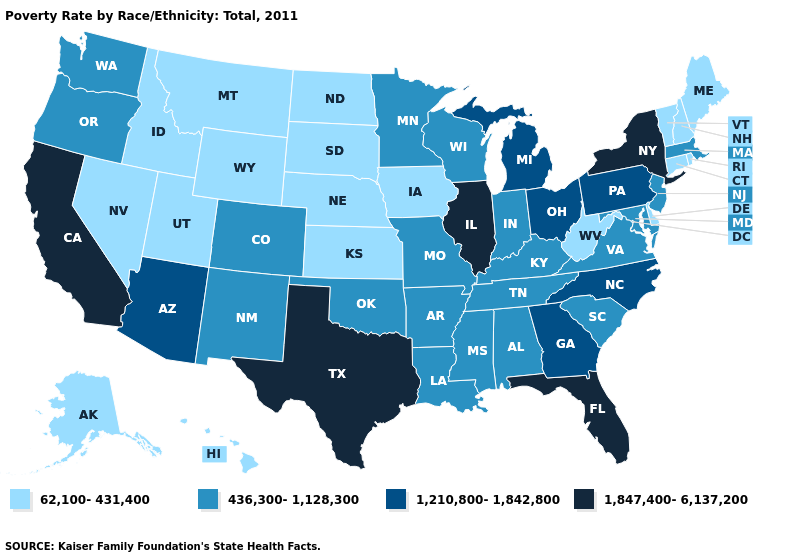What is the lowest value in the USA?
Give a very brief answer. 62,100-431,400. What is the value of North Dakota?
Write a very short answer. 62,100-431,400. How many symbols are there in the legend?
Quick response, please. 4. What is the highest value in the USA?
Be succinct. 1,847,400-6,137,200. Name the states that have a value in the range 436,300-1,128,300?
Keep it brief. Alabama, Arkansas, Colorado, Indiana, Kentucky, Louisiana, Maryland, Massachusetts, Minnesota, Mississippi, Missouri, New Jersey, New Mexico, Oklahoma, Oregon, South Carolina, Tennessee, Virginia, Washington, Wisconsin. Name the states that have a value in the range 62,100-431,400?
Concise answer only. Alaska, Connecticut, Delaware, Hawaii, Idaho, Iowa, Kansas, Maine, Montana, Nebraska, Nevada, New Hampshire, North Dakota, Rhode Island, South Dakota, Utah, Vermont, West Virginia, Wyoming. Does New Hampshire have the same value as Utah?
Keep it brief. Yes. What is the value of Arkansas?
Be succinct. 436,300-1,128,300. Name the states that have a value in the range 1,847,400-6,137,200?
Concise answer only. California, Florida, Illinois, New York, Texas. Among the states that border Louisiana , does Arkansas have the highest value?
Write a very short answer. No. Does New Jersey have the same value as Virginia?
Be succinct. Yes. Does Hawaii have a higher value than Mississippi?
Short answer required. No. Does Florida have the highest value in the USA?
Short answer required. Yes. What is the value of Arkansas?
Give a very brief answer. 436,300-1,128,300. Among the states that border Iowa , does Minnesota have the highest value?
Quick response, please. No. 